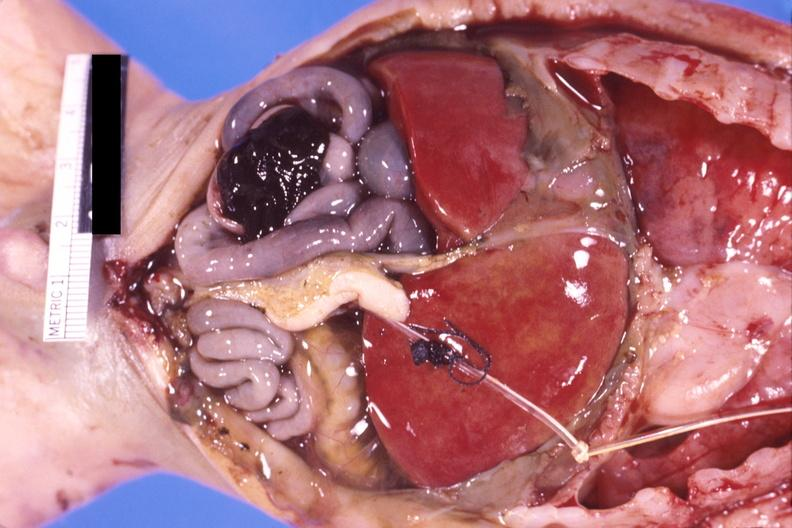where is this area in the body?
Answer the question using a single word or phrase. Abdomen 